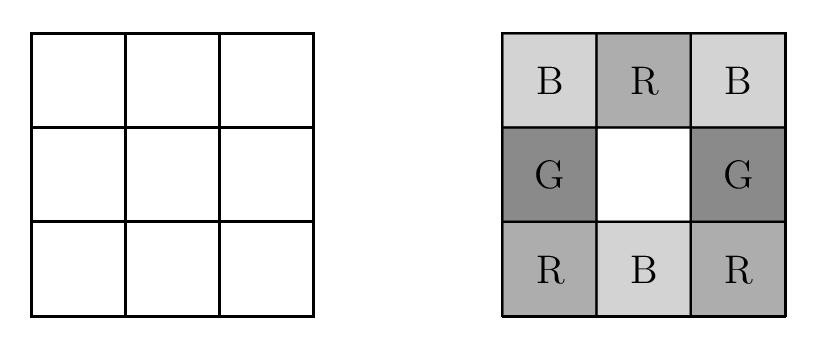Can you explain why certain configurations might be invalid in this setup? In configurations where the requirement that each $2\times 2$ square must contain one square of each color is not met, the setup becomes invalid. For example, if two squares within any $2\times 2$ area are the same color, the configuration does not satisfy the problem's constraints. Such invalid setups occur when there is an overlap in color assignment that disregards the strict distribution rule, leading to redundant color placements. Keeping track of prior color placements critically affects the validity of subsequent squares in the grid. 